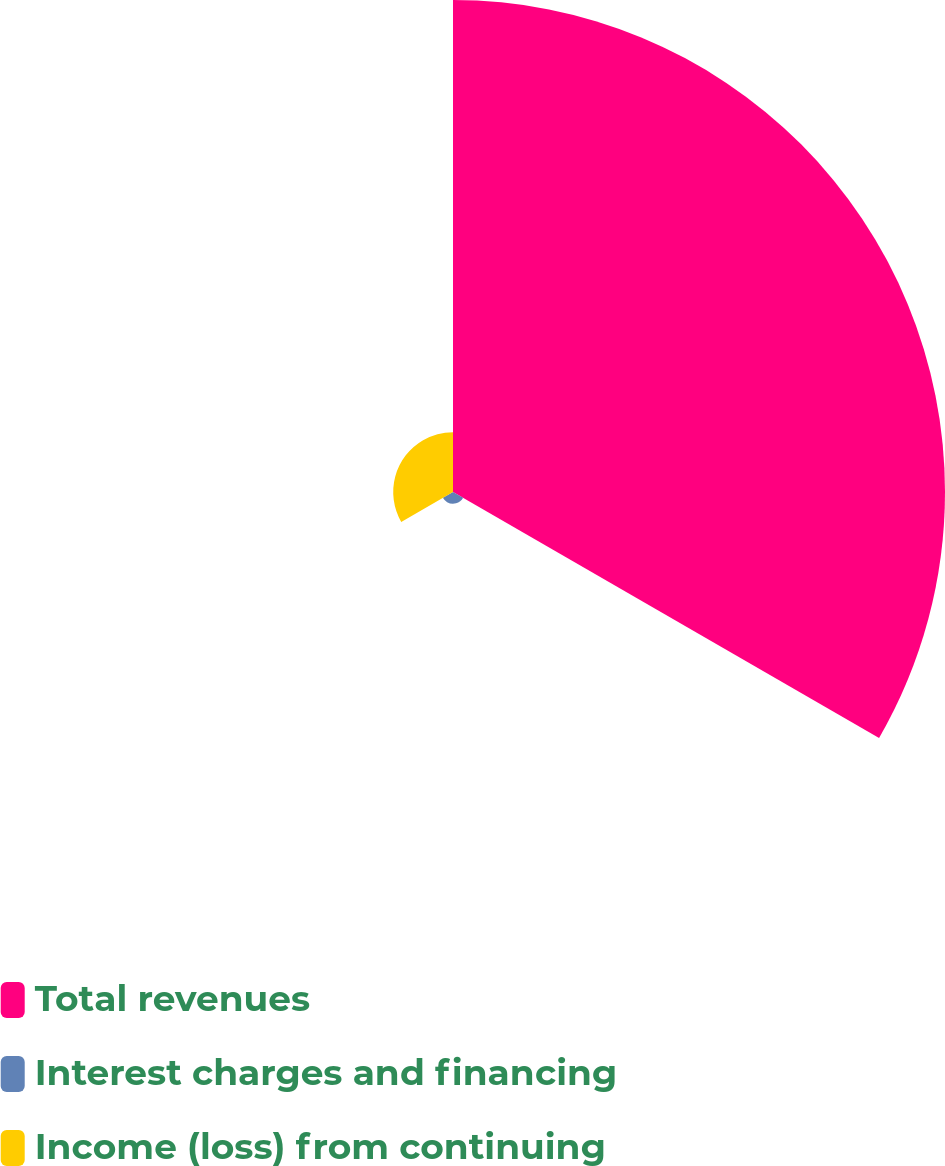<chart> <loc_0><loc_0><loc_500><loc_500><pie_chart><fcel>Total revenues<fcel>Interest charges and financing<fcel>Income (loss) from continuing<nl><fcel>87.31%<fcel>2.08%<fcel>10.61%<nl></chart> 